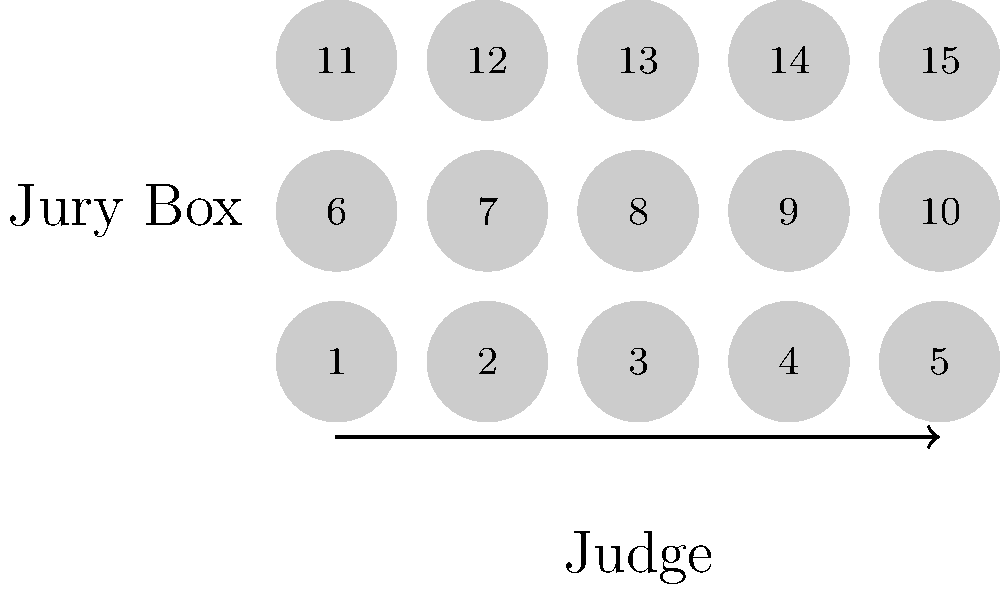In a courtroom setup for jury selection, the diagram shows 15 potential juror seats arranged in a 5x3 grid. The judge is positioned at the bottom center. If you want to ensure that no two jurors with consecutive numbers are seated next to each other (horizontally, vertically, or diagonally), what is the maximum number of jurors that can be selected while adhering to this rule? To solve this problem, we need to follow these steps:

1. Understand the constraint: No two jurors with consecutive numbers can be adjacent (horizontally, vertically, or diagonally).

2. Analyze the seating arrangement:
   - There are 15 seats in total, arranged in a 5x3 grid.
   - Each seat is surrounded by up to 8 adjacent seats (fewer for edge and corner seats).

3. Start placing jurors strategically:
   - Begin with seat 1, as it's in a corner and has the fewest adjacent seats.
   - After placing a juror, we can't use any of the adjacent seats for the next consecutive number.

4. Optimal placement:
   - Seat 1: Place the first juror here.
   - Seat 5: This is not adjacent to seat 1, so we can place the second juror here.
   - Seat 9: Not adjacent to 1 or 5, place the third juror here.
   - Seat 13: Not adjacent to previous selections, place the fourth juror here.
   - Seat 3: This completes the maximum non-adjacent placement.

5. Verify:
   - Check that no two selected seats are adjacent to each other.
   - Confirm that no other seat can be added without violating the rule.

6. Count the selected seats:
   - We have placed jurors in seats 1, 3, 5, 9, and 13.
   - This gives us a total of 5 jurors.

Therefore, the maximum number of jurors that can be selected while adhering to the given rule is 5.
Answer: 5 jurors 